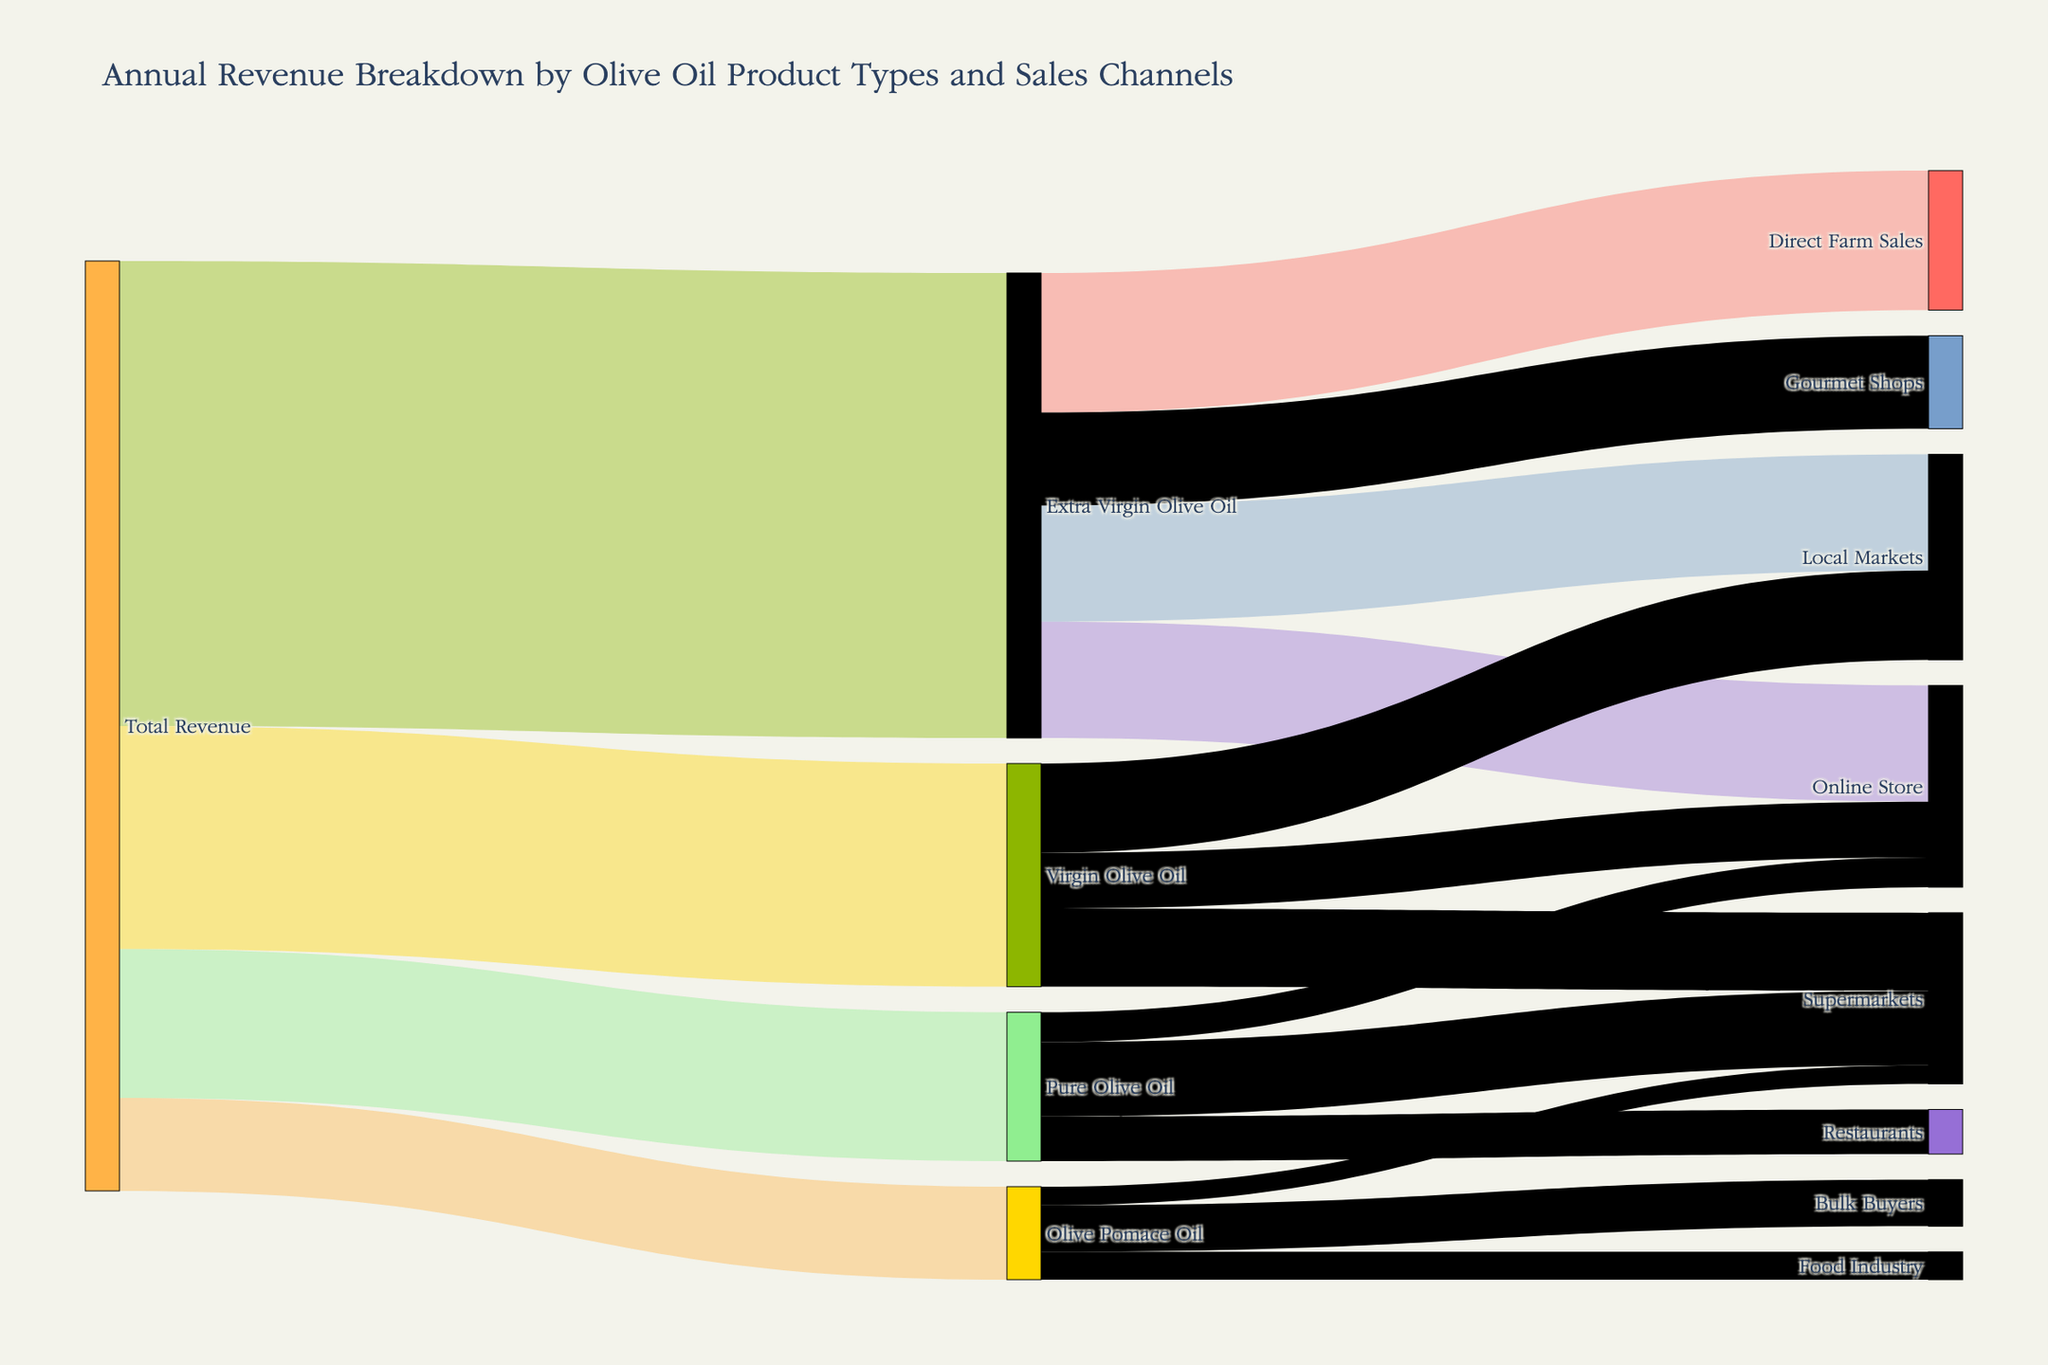What is the total revenue from Extra Virgin Olive Oil? The diagram shows a link from Total Revenue to Extra Virgin Olive Oil with a value of 2,500,000.
Answer: 2,500,000 Which product type contributes the least to Total Revenue? Comparing all product types linked to Total Revenue, Olive Pomace Oil has the smallest value of 500,000.
Answer: Olive Pomace Oil How much revenue comes from Direct Farm Sales of Extra Virgin Olive Oil? The link from Extra Virgin Olive Oil to Direct Farm Sales shows a value of 750,000.
Answer: 750,000 What is the combined revenue from Local Markets and Online Store for Extra Virgin Olive Oil? The link values are 625,000 from Extra Virgin Olive Oil to Local Markets and 625,000 to Online Store. Summing these gives 625,000 + 625,000 = 1,250,000.
Answer: 1,250,000 Which sales channel brings in the most revenue for Virgin Olive Oil? By comparing the link values from Virgin Olive Oil, Local Markets has the highest value of 480,000.
Answer: Local Markets What is the difference in revenue between Pure Olive Oil sold to Supermarkets and to Restaurants? The revenue to Supermarkets is 400,000 and to Restaurants is 240,000. The difference is 400,000 - 240,000 = 160,000.
Answer: 160,000 How much total revenue is generated from Online Store across all olive oil product types? Summing the Online Store values: 625,000 (Extra Virgin) + 300,000 (Virgin) + 160,000 (Pure) = 1,085,000.
Answer: 1,085,000 Which sales channel does not sell Olive Pomace Oil? Reviewing all links from Olive Pomace Oil, it is seen in Bulk Buyers, Food Industry, and Supermarkets, but not in Direct Farm Sales, Local Markets, Online Store, or Gourmet Shops.
Answer: Direct Farm Sales, Local Markets, Online Store, Gourmet Shops What is the ratio of revenue from Gourmet Shops to Direct Farm Sales for Extra Virgin Olive Oil? Revenue from Gourmet Shops is 500,000 and from Direct Farm Sales is 750,000. The ratio is 500,000 / 750,000, which simplifies to 2/3.
Answer: 2/3 How does the revenue from Bulk Buyers compare to that from Supermarkets for Olive Pomace Oil? The revenue from Bulk Buyers is 250,000 and from Supermarkets is 100,000. Bulk Buyers bring in more revenue.
Answer: Bulk Buyers bring in more 